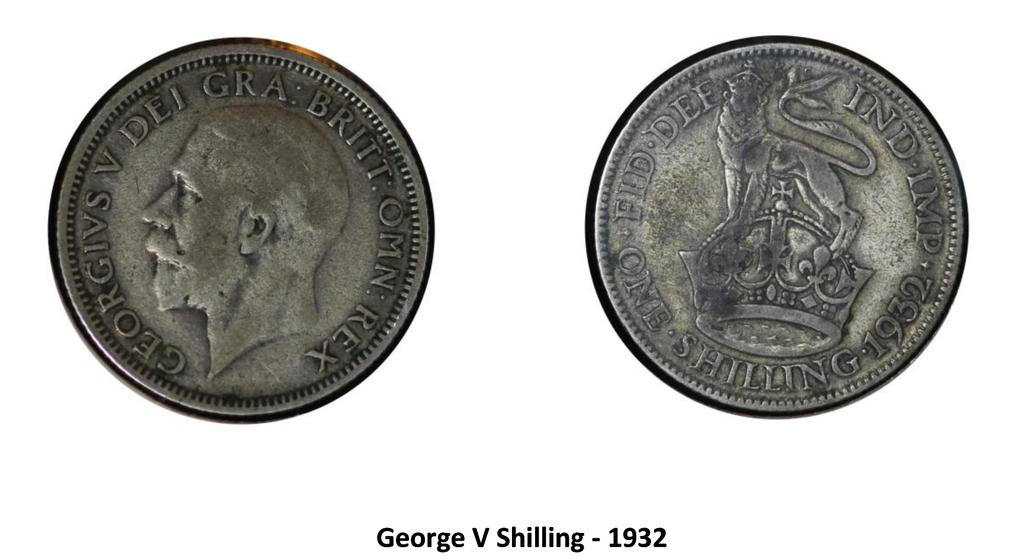<image>
Summarize the visual content of the image. Pictures of the front and back of a George V Shilling circa 1932 